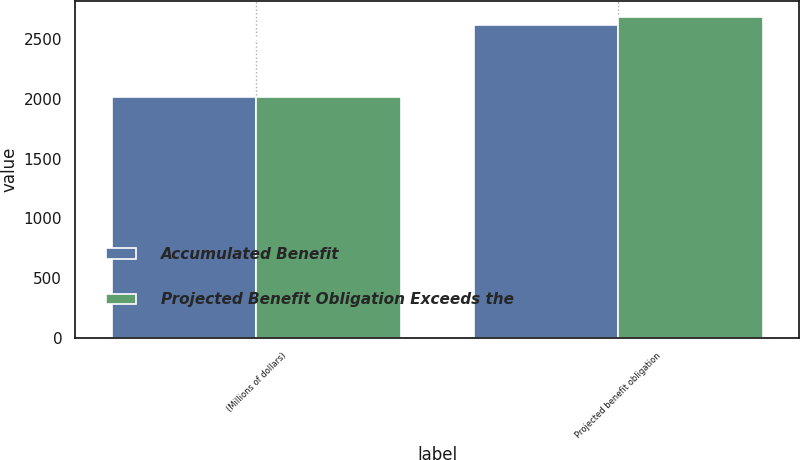Convert chart. <chart><loc_0><loc_0><loc_500><loc_500><stacked_bar_chart><ecel><fcel>(Millions of dollars)<fcel>Projected benefit obligation<nl><fcel>Accumulated Benefit<fcel>2016<fcel>2616<nl><fcel>Projected Benefit Obligation Exceeds the<fcel>2016<fcel>2682<nl></chart> 